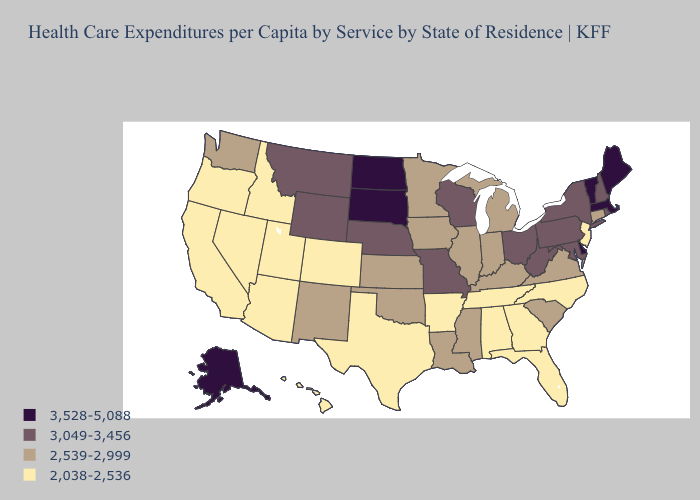Among the states that border Wisconsin , which have the lowest value?
Concise answer only. Illinois, Iowa, Michigan, Minnesota. What is the lowest value in the South?
Answer briefly. 2,038-2,536. Name the states that have a value in the range 3,528-5,088?
Short answer required. Alaska, Delaware, Maine, Massachusetts, North Dakota, South Dakota, Vermont. Is the legend a continuous bar?
Answer briefly. No. What is the value of Massachusetts?
Give a very brief answer. 3,528-5,088. Does Virginia have the lowest value in the USA?
Keep it brief. No. Which states have the lowest value in the Northeast?
Give a very brief answer. New Jersey. What is the value of Vermont?
Concise answer only. 3,528-5,088. Name the states that have a value in the range 2,038-2,536?
Answer briefly. Alabama, Arizona, Arkansas, California, Colorado, Florida, Georgia, Hawaii, Idaho, Nevada, New Jersey, North Carolina, Oregon, Tennessee, Texas, Utah. What is the value of Kentucky?
Short answer required. 2,539-2,999. Does the first symbol in the legend represent the smallest category?
Quick response, please. No. Among the states that border Illinois , which have the lowest value?
Concise answer only. Indiana, Iowa, Kentucky. What is the value of Wyoming?
Concise answer only. 3,049-3,456. Which states have the lowest value in the USA?
Quick response, please. Alabama, Arizona, Arkansas, California, Colorado, Florida, Georgia, Hawaii, Idaho, Nevada, New Jersey, North Carolina, Oregon, Tennessee, Texas, Utah. 